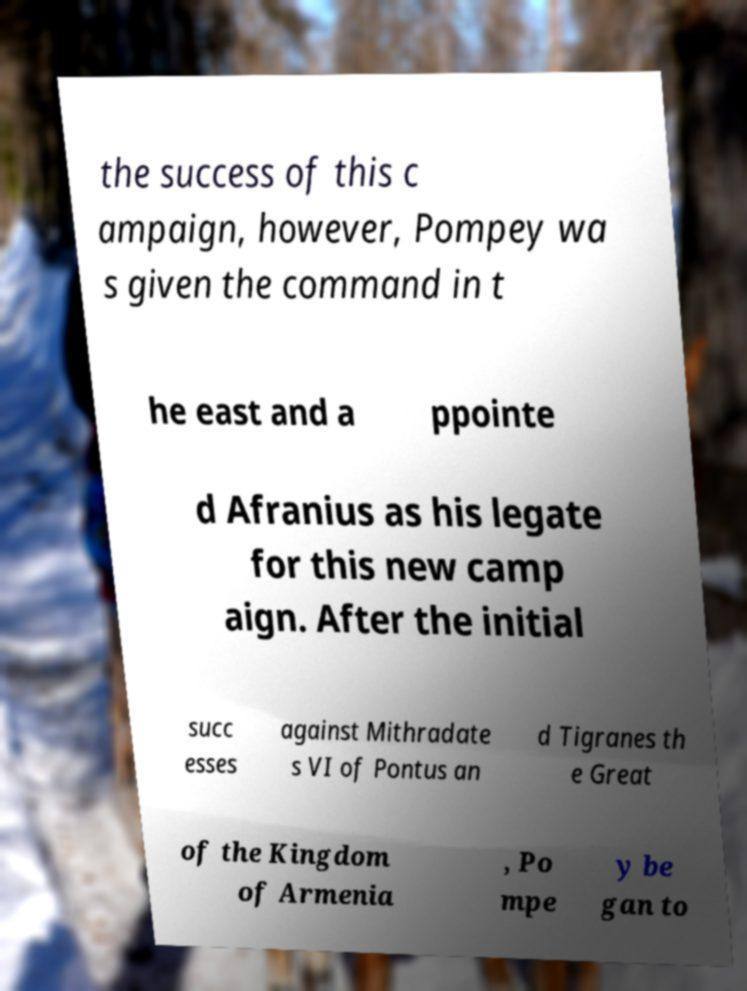Can you accurately transcribe the text from the provided image for me? the success of this c ampaign, however, Pompey wa s given the command in t he east and a ppointe d Afranius as his legate for this new camp aign. After the initial succ esses against Mithradate s VI of Pontus an d Tigranes th e Great of the Kingdom of Armenia , Po mpe y be gan to 